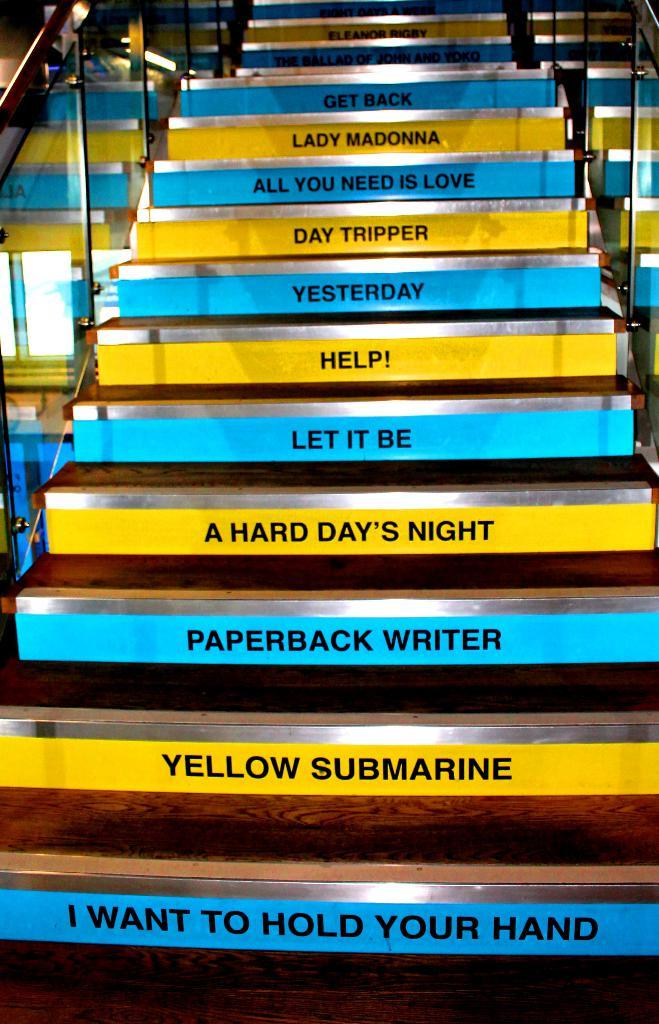<image>
Present a compact description of the photo's key features. A staircase has Beatles songs on the back of each step, starting with I Want to Hold Your Hand at the bottom. 